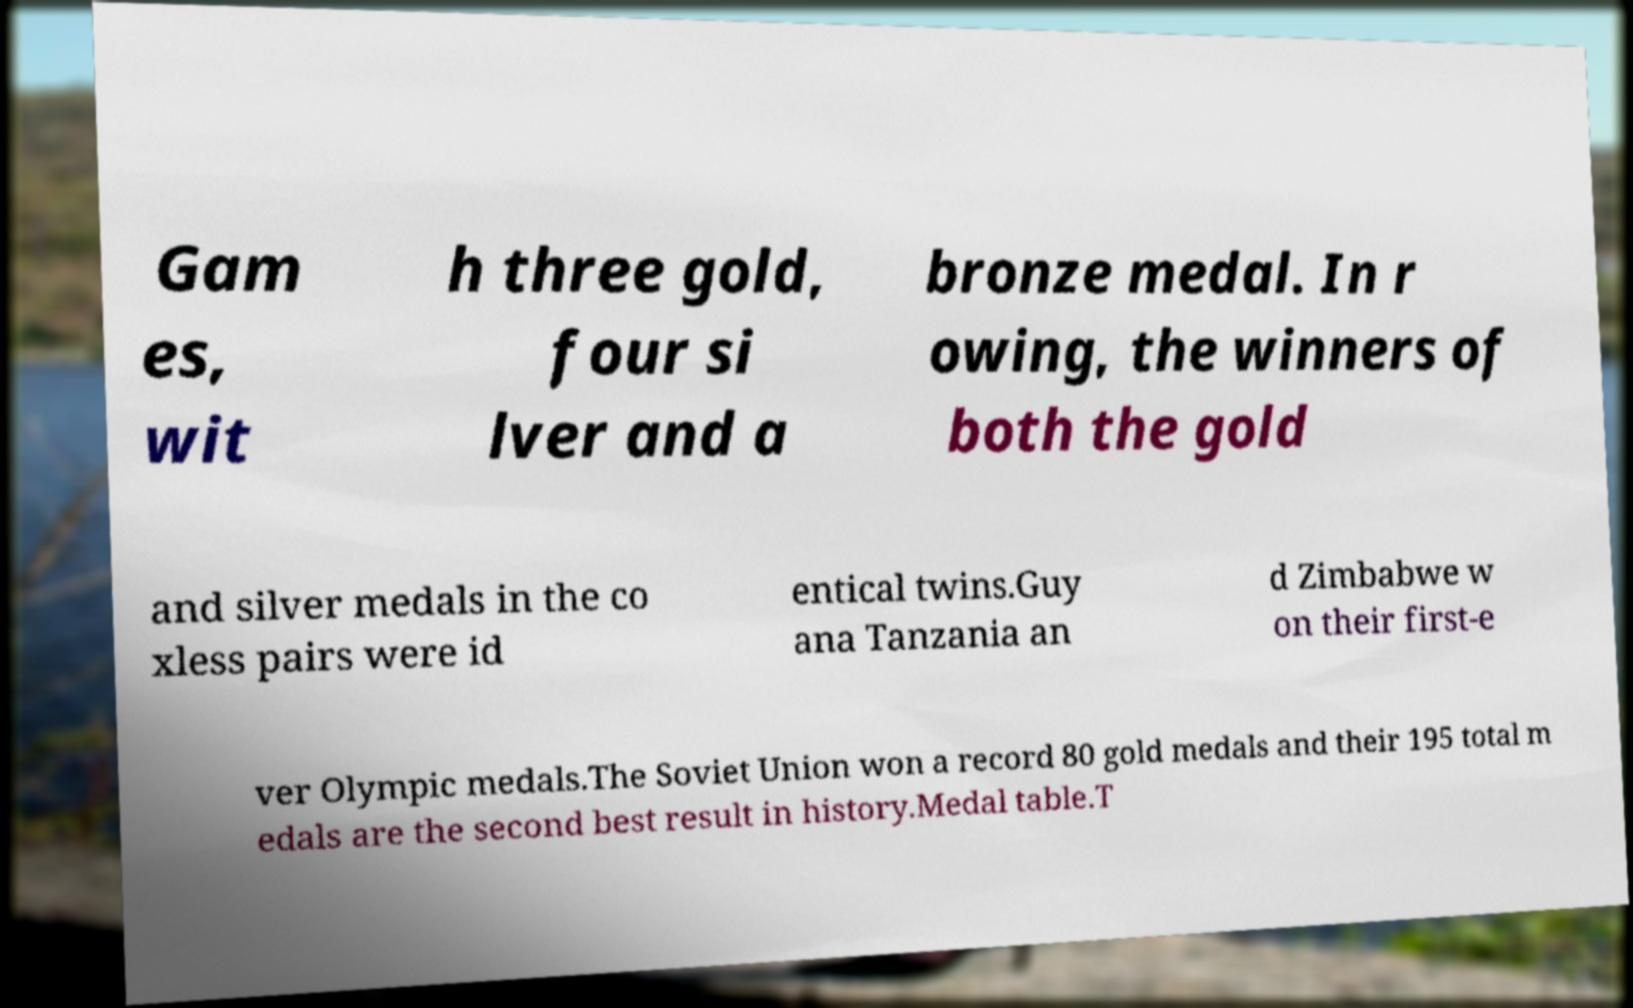Can you accurately transcribe the text from the provided image for me? Gam es, wit h three gold, four si lver and a bronze medal. In r owing, the winners of both the gold and silver medals in the co xless pairs were id entical twins.Guy ana Tanzania an d Zimbabwe w on their first-e ver Olympic medals.The Soviet Union won a record 80 gold medals and their 195 total m edals are the second best result in history.Medal table.T 